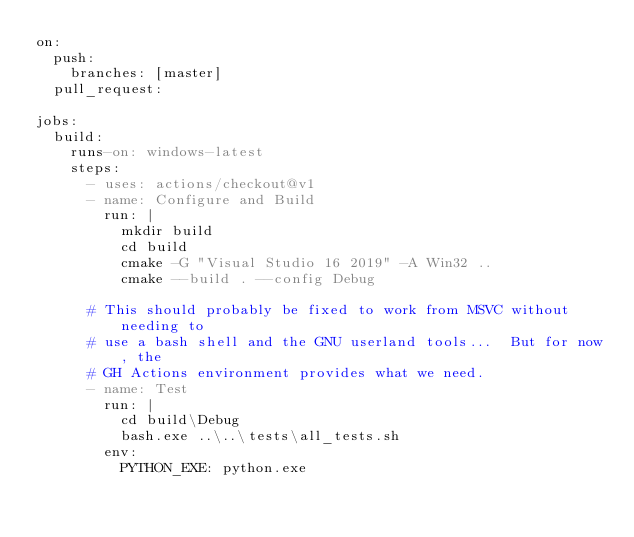Convert code to text. <code><loc_0><loc_0><loc_500><loc_500><_YAML_>on:
  push:
    branches: [master]
  pull_request:

jobs:
  build:
    runs-on: windows-latest
    steps:
      - uses: actions/checkout@v1
      - name: Configure and Build
        run: |
          mkdir build
          cd build
          cmake -G "Visual Studio 16 2019" -A Win32 ..
          cmake --build . --config Debug

      # This should probably be fixed to work from MSVC without needing to
      # use a bash shell and the GNU userland tools...  But for now, the
      # GH Actions environment provides what we need.
      - name: Test
        run: |
          cd build\Debug
          bash.exe ..\..\tests\all_tests.sh
        env:
          PYTHON_EXE: python.exe
</code> 